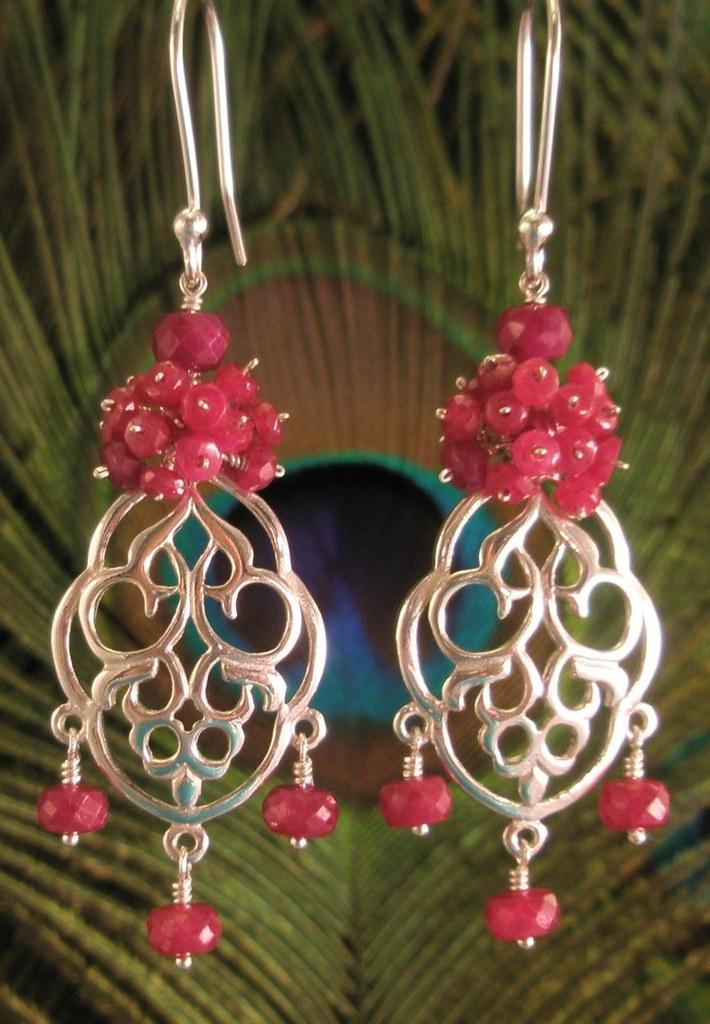What type of accessory is visible in the image? There are earrings in the image. What can be seen in the background of the image? There is a peacock's feather in the background of the image. What type of songs can be heard coming from the apparatus in the image? There is no apparatus present in the image, and therefore no songs can be heard coming from it. 